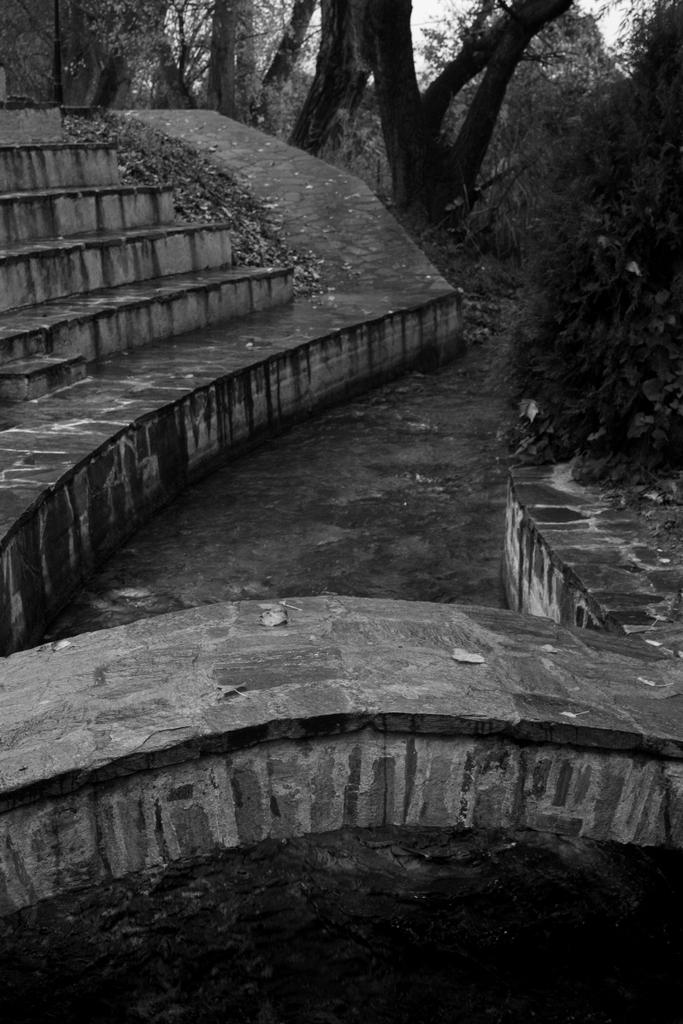What type of structure is present in the image? There are stairs in the image. What can be seen in the background of the image? Trees are visible in the background of the image. What is the color scheme of the image? The image is in black and white. What type of harmony is being displayed between the trees and the stairs in the image? There is no indication of harmony between the trees and the stairs in the image, as they are separate elements in the scene. 